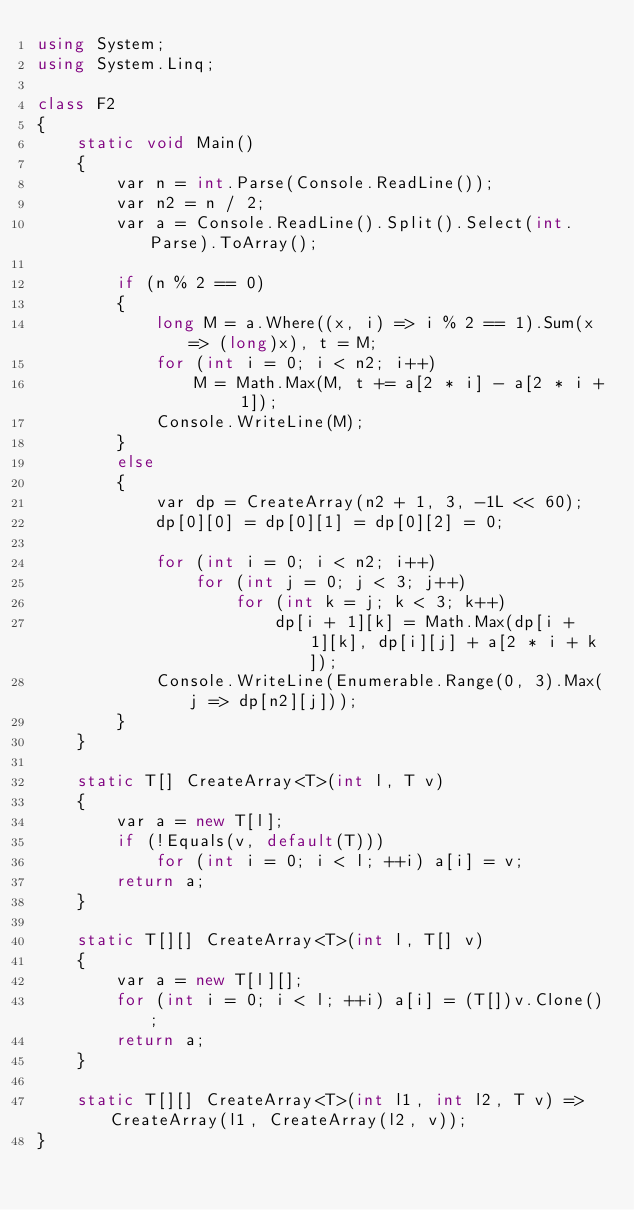Convert code to text. <code><loc_0><loc_0><loc_500><loc_500><_C#_>using System;
using System.Linq;

class F2
{
	static void Main()
	{
		var n = int.Parse(Console.ReadLine());
		var n2 = n / 2;
		var a = Console.ReadLine().Split().Select(int.Parse).ToArray();

		if (n % 2 == 0)
		{
			long M = a.Where((x, i) => i % 2 == 1).Sum(x => (long)x), t = M;
			for (int i = 0; i < n2; i++)
				M = Math.Max(M, t += a[2 * i] - a[2 * i + 1]);
			Console.WriteLine(M);
		}
		else
		{
			var dp = CreateArray(n2 + 1, 3, -1L << 60);
			dp[0][0] = dp[0][1] = dp[0][2] = 0;

			for (int i = 0; i < n2; i++)
				for (int j = 0; j < 3; j++)
					for (int k = j; k < 3; k++)
						dp[i + 1][k] = Math.Max(dp[i + 1][k], dp[i][j] + a[2 * i + k]);
			Console.WriteLine(Enumerable.Range(0, 3).Max(j => dp[n2][j]));
		}
	}

	static T[] CreateArray<T>(int l, T v)
	{
		var a = new T[l];
		if (!Equals(v, default(T)))
			for (int i = 0; i < l; ++i) a[i] = v;
		return a;
	}

	static T[][] CreateArray<T>(int l, T[] v)
	{
		var a = new T[l][];
		for (int i = 0; i < l; ++i) a[i] = (T[])v.Clone();
		return a;
	}

	static T[][] CreateArray<T>(int l1, int l2, T v) => CreateArray(l1, CreateArray(l2, v));
}
</code> 